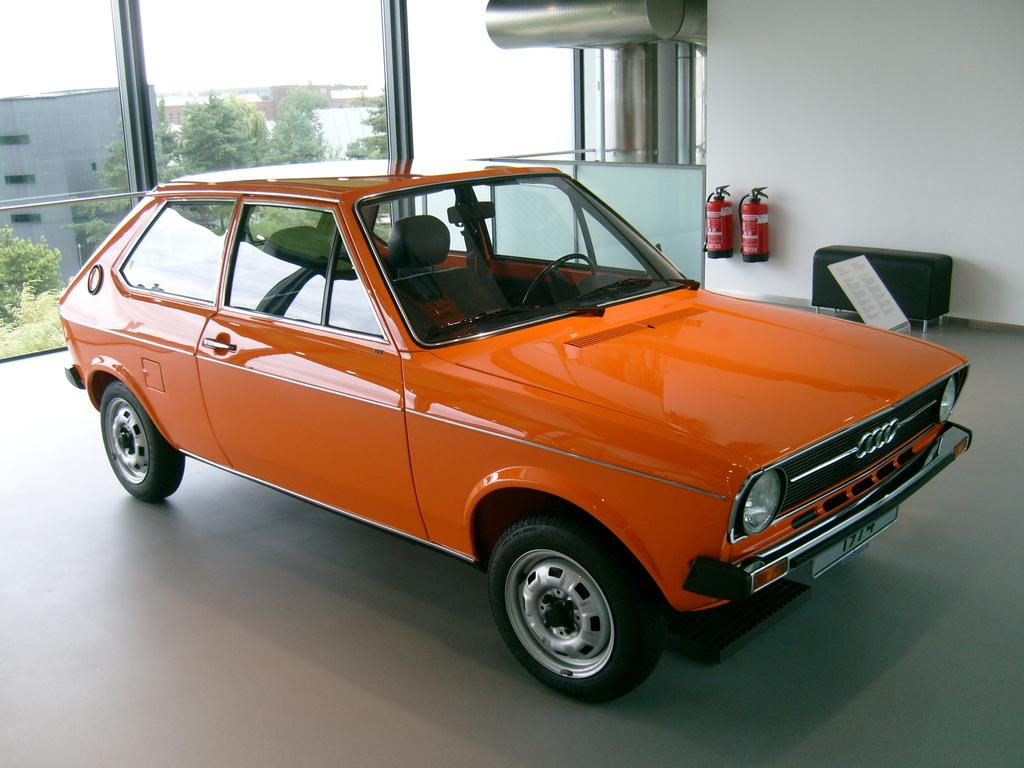What is on the floor in the image? There is a vehicle on the floor in the image. What can be seen through the glass in the image? Buildings, trees, and the sky can be seen through the glass in the image. How many hydrants are visible in the image? There are two hydrants in the image. What is hanging on the wall in the image? There is a poster in the image. What type of furniture is present in the image? There is a stool in the image. What is the background of the image made of? The background of the image includes a wall. What type of property does the uncle own in the image? There is no uncle or property mentioned in the image. How does the coastline look in the image? There is no coastline visible in the image. 